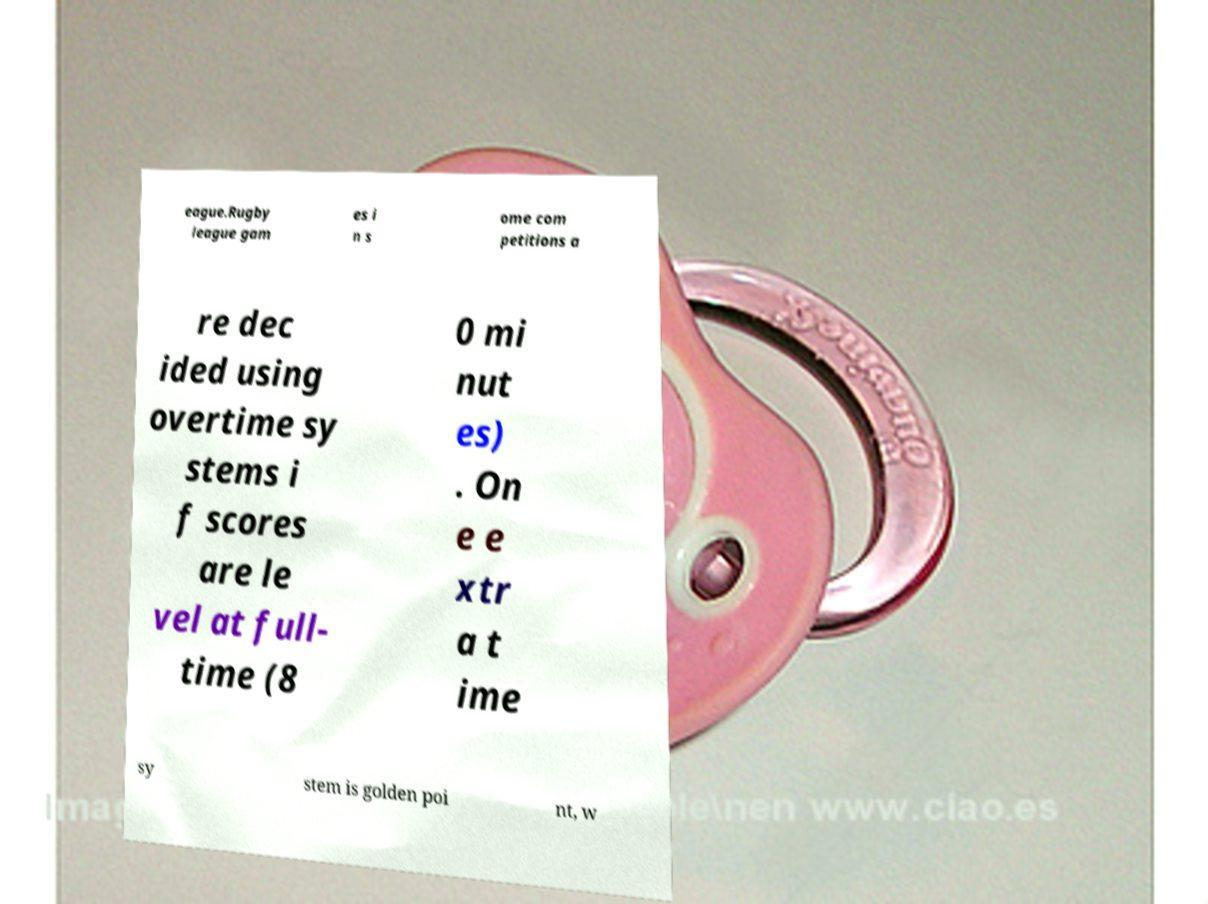Please identify and transcribe the text found in this image. eague.Rugby league gam es i n s ome com petitions a re dec ided using overtime sy stems i f scores are le vel at full- time (8 0 mi nut es) . On e e xtr a t ime sy stem is golden poi nt, w 